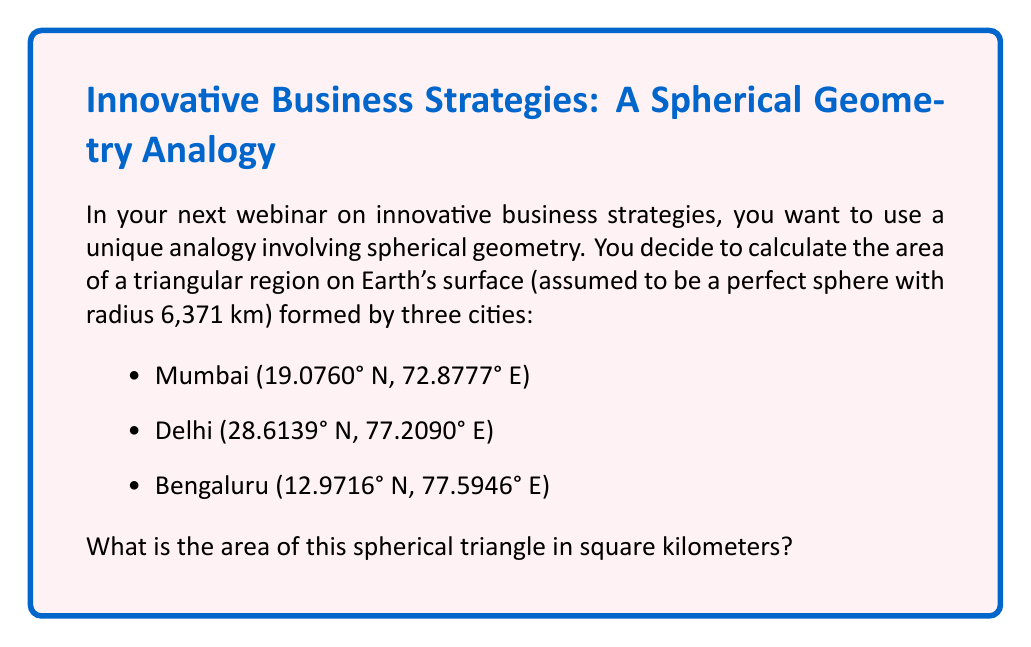Can you solve this math problem? To solve this problem, we'll use the following steps:

1. Convert the latitude and longitude coordinates to radians.
2. Calculate the angular distances between the cities using the great circle distance formula.
3. Use these angular distances as side lengths in the spherical excess formula to find the area.

Step 1: Convert coordinates to radians
$$\text{Mumbai}: (0.3329, 1.2716)$$
$$\text{Delhi}: (0.4992, 1.3474)$$
$$\text{Bengaluru}: (0.2264, 1.3544)$$

Step 2: Calculate angular distances (a, b, c) using the great circle distance formula:
$$\cos(d) = \sin(\phi_1)\sin(\phi_2) + \cos(\phi_1)\cos(\phi_2)\cos(\Delta\lambda)$$

For Mumbai-Delhi (a):
$$a = \arccos(\sin(0.3329)\sin(0.4992) + \cos(0.3329)\cos(0.4992)\cos(1.3474-1.2716))$$
$$a = 0.2710$$

Similarly, for Delhi-Bengaluru (b) and Bengaluru-Mumbai (c):
$$b = 0.4703$$
$$c = 0.2935$$

Step 3: Use the spherical excess formula to calculate the area:
$$A = R^2 \cdot E$$
Where $R$ is the Earth's radius and $E$ is the spherical excess given by:
$$E = A + B + C - \pi$$
$$\cos(A) = \frac{\cos(a) - \cos(b)\cos(c)}{\sin(b)\sin(c)}$$

Calculate A, B, and C:
$$A = \arccos(\frac{\cos(0.2710) - \cos(0.4703)\cos(0.2935)}{\sin(0.4703)\sin(0.2935)}) = 1.5708$$
$$B = \arccos(\frac{\cos(0.4703) - \cos(0.2710)\cos(0.2935)}{\sin(0.2710)\sin(0.2935)}) = 1.0472$$
$$C = \arccos(\frac{\cos(0.2935) - \cos(0.2710)\cos(0.4703)}{\sin(0.2710)\sin(0.4703)}) = 1.0472$$

Spherical excess:
$$E = 1.5708 + 1.0472 + 1.0472 - \pi = 0.5708$$

Final area:
$$A = (6371)^2 \cdot 0.5708 = 23,132,330 \text{ km}^2$$
Answer: 23,132,330 km² 